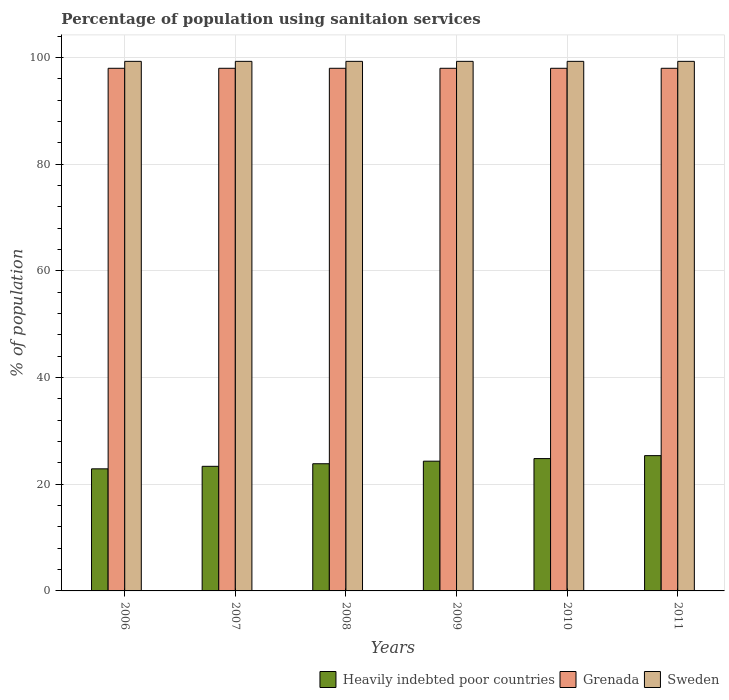How many different coloured bars are there?
Provide a short and direct response. 3. How many bars are there on the 4th tick from the right?
Your answer should be very brief. 3. In how many cases, is the number of bars for a given year not equal to the number of legend labels?
Keep it short and to the point. 0. What is the percentage of population using sanitaion services in Heavily indebted poor countries in 2009?
Keep it short and to the point. 24.33. Across all years, what is the maximum percentage of population using sanitaion services in Heavily indebted poor countries?
Offer a terse response. 25.37. Across all years, what is the minimum percentage of population using sanitaion services in Heavily indebted poor countries?
Offer a very short reply. 22.89. In which year was the percentage of population using sanitaion services in Sweden maximum?
Provide a succinct answer. 2006. What is the total percentage of population using sanitaion services in Grenada in the graph?
Make the answer very short. 588. What is the difference between the percentage of population using sanitaion services in Sweden in 2008 and that in 2011?
Provide a succinct answer. 0. What is the difference between the percentage of population using sanitaion services in Heavily indebted poor countries in 2010 and the percentage of population using sanitaion services in Sweden in 2006?
Make the answer very short. -74.49. What is the average percentage of population using sanitaion services in Sweden per year?
Give a very brief answer. 99.3. In the year 2010, what is the difference between the percentage of population using sanitaion services in Grenada and percentage of population using sanitaion services in Heavily indebted poor countries?
Give a very brief answer. 73.19. In how many years, is the percentage of population using sanitaion services in Heavily indebted poor countries greater than 76 %?
Your answer should be very brief. 0. What is the ratio of the percentage of population using sanitaion services in Heavily indebted poor countries in 2007 to that in 2011?
Keep it short and to the point. 0.92. Is the percentage of population using sanitaion services in Sweden in 2007 less than that in 2011?
Make the answer very short. No. What is the difference between the highest and the second highest percentage of population using sanitaion services in Heavily indebted poor countries?
Your answer should be compact. 0.55. What is the difference between the highest and the lowest percentage of population using sanitaion services in Sweden?
Your response must be concise. 0. In how many years, is the percentage of population using sanitaion services in Heavily indebted poor countries greater than the average percentage of population using sanitaion services in Heavily indebted poor countries taken over all years?
Provide a short and direct response. 3. What does the 3rd bar from the right in 2008 represents?
Your answer should be very brief. Heavily indebted poor countries. How many years are there in the graph?
Give a very brief answer. 6. How are the legend labels stacked?
Offer a terse response. Horizontal. What is the title of the graph?
Your response must be concise. Percentage of population using sanitaion services. Does "World" appear as one of the legend labels in the graph?
Your answer should be very brief. No. What is the label or title of the X-axis?
Offer a terse response. Years. What is the label or title of the Y-axis?
Your answer should be compact. % of population. What is the % of population of Heavily indebted poor countries in 2006?
Give a very brief answer. 22.89. What is the % of population of Sweden in 2006?
Your response must be concise. 99.3. What is the % of population of Heavily indebted poor countries in 2007?
Your answer should be compact. 23.37. What is the % of population of Sweden in 2007?
Make the answer very short. 99.3. What is the % of population of Heavily indebted poor countries in 2008?
Offer a very short reply. 23.85. What is the % of population in Sweden in 2008?
Your answer should be compact. 99.3. What is the % of population of Heavily indebted poor countries in 2009?
Provide a succinct answer. 24.33. What is the % of population in Grenada in 2009?
Make the answer very short. 98. What is the % of population of Sweden in 2009?
Make the answer very short. 99.3. What is the % of population in Heavily indebted poor countries in 2010?
Your response must be concise. 24.81. What is the % of population of Grenada in 2010?
Provide a succinct answer. 98. What is the % of population in Sweden in 2010?
Your response must be concise. 99.3. What is the % of population in Heavily indebted poor countries in 2011?
Offer a very short reply. 25.37. What is the % of population in Sweden in 2011?
Your answer should be compact. 99.3. Across all years, what is the maximum % of population of Heavily indebted poor countries?
Give a very brief answer. 25.37. Across all years, what is the maximum % of population of Grenada?
Provide a short and direct response. 98. Across all years, what is the maximum % of population in Sweden?
Offer a terse response. 99.3. Across all years, what is the minimum % of population of Heavily indebted poor countries?
Give a very brief answer. 22.89. Across all years, what is the minimum % of population of Grenada?
Your response must be concise. 98. Across all years, what is the minimum % of population of Sweden?
Offer a terse response. 99.3. What is the total % of population of Heavily indebted poor countries in the graph?
Your answer should be compact. 144.62. What is the total % of population of Grenada in the graph?
Offer a terse response. 588. What is the total % of population of Sweden in the graph?
Offer a very short reply. 595.8. What is the difference between the % of population of Heavily indebted poor countries in 2006 and that in 2007?
Your answer should be compact. -0.47. What is the difference between the % of population of Sweden in 2006 and that in 2007?
Your response must be concise. 0. What is the difference between the % of population of Heavily indebted poor countries in 2006 and that in 2008?
Your answer should be very brief. -0.95. What is the difference between the % of population in Grenada in 2006 and that in 2008?
Give a very brief answer. 0. What is the difference between the % of population of Heavily indebted poor countries in 2006 and that in 2009?
Your answer should be very brief. -1.43. What is the difference between the % of population of Grenada in 2006 and that in 2009?
Provide a short and direct response. 0. What is the difference between the % of population of Heavily indebted poor countries in 2006 and that in 2010?
Provide a succinct answer. -1.92. What is the difference between the % of population in Sweden in 2006 and that in 2010?
Give a very brief answer. 0. What is the difference between the % of population in Heavily indebted poor countries in 2006 and that in 2011?
Offer a terse response. -2.47. What is the difference between the % of population in Sweden in 2006 and that in 2011?
Keep it short and to the point. 0. What is the difference between the % of population of Heavily indebted poor countries in 2007 and that in 2008?
Give a very brief answer. -0.48. What is the difference between the % of population in Grenada in 2007 and that in 2008?
Ensure brevity in your answer.  0. What is the difference between the % of population of Sweden in 2007 and that in 2008?
Keep it short and to the point. 0. What is the difference between the % of population in Heavily indebted poor countries in 2007 and that in 2009?
Your answer should be compact. -0.96. What is the difference between the % of population of Heavily indebted poor countries in 2007 and that in 2010?
Ensure brevity in your answer.  -1.45. What is the difference between the % of population of Grenada in 2007 and that in 2010?
Your answer should be very brief. 0. What is the difference between the % of population in Heavily indebted poor countries in 2007 and that in 2011?
Provide a succinct answer. -2. What is the difference between the % of population of Heavily indebted poor countries in 2008 and that in 2009?
Offer a terse response. -0.48. What is the difference between the % of population of Grenada in 2008 and that in 2009?
Your answer should be compact. 0. What is the difference between the % of population of Sweden in 2008 and that in 2009?
Provide a short and direct response. 0. What is the difference between the % of population in Heavily indebted poor countries in 2008 and that in 2010?
Give a very brief answer. -0.97. What is the difference between the % of population of Sweden in 2008 and that in 2010?
Offer a very short reply. 0. What is the difference between the % of population in Heavily indebted poor countries in 2008 and that in 2011?
Offer a terse response. -1.52. What is the difference between the % of population in Heavily indebted poor countries in 2009 and that in 2010?
Ensure brevity in your answer.  -0.49. What is the difference between the % of population in Grenada in 2009 and that in 2010?
Give a very brief answer. 0. What is the difference between the % of population of Heavily indebted poor countries in 2009 and that in 2011?
Offer a terse response. -1.04. What is the difference between the % of population of Grenada in 2009 and that in 2011?
Offer a very short reply. 0. What is the difference between the % of population in Sweden in 2009 and that in 2011?
Give a very brief answer. 0. What is the difference between the % of population of Heavily indebted poor countries in 2010 and that in 2011?
Provide a succinct answer. -0.55. What is the difference between the % of population in Grenada in 2010 and that in 2011?
Your answer should be compact. 0. What is the difference between the % of population in Sweden in 2010 and that in 2011?
Offer a very short reply. 0. What is the difference between the % of population in Heavily indebted poor countries in 2006 and the % of population in Grenada in 2007?
Your answer should be compact. -75.11. What is the difference between the % of population in Heavily indebted poor countries in 2006 and the % of population in Sweden in 2007?
Provide a succinct answer. -76.41. What is the difference between the % of population of Grenada in 2006 and the % of population of Sweden in 2007?
Your response must be concise. -1.3. What is the difference between the % of population of Heavily indebted poor countries in 2006 and the % of population of Grenada in 2008?
Your answer should be compact. -75.11. What is the difference between the % of population in Heavily indebted poor countries in 2006 and the % of population in Sweden in 2008?
Make the answer very short. -76.41. What is the difference between the % of population of Heavily indebted poor countries in 2006 and the % of population of Grenada in 2009?
Offer a very short reply. -75.11. What is the difference between the % of population of Heavily indebted poor countries in 2006 and the % of population of Sweden in 2009?
Make the answer very short. -76.41. What is the difference between the % of population of Grenada in 2006 and the % of population of Sweden in 2009?
Offer a terse response. -1.3. What is the difference between the % of population of Heavily indebted poor countries in 2006 and the % of population of Grenada in 2010?
Give a very brief answer. -75.11. What is the difference between the % of population in Heavily indebted poor countries in 2006 and the % of population in Sweden in 2010?
Provide a short and direct response. -76.41. What is the difference between the % of population in Grenada in 2006 and the % of population in Sweden in 2010?
Your answer should be very brief. -1.3. What is the difference between the % of population of Heavily indebted poor countries in 2006 and the % of population of Grenada in 2011?
Ensure brevity in your answer.  -75.11. What is the difference between the % of population of Heavily indebted poor countries in 2006 and the % of population of Sweden in 2011?
Offer a terse response. -76.41. What is the difference between the % of population of Grenada in 2006 and the % of population of Sweden in 2011?
Provide a short and direct response. -1.3. What is the difference between the % of population of Heavily indebted poor countries in 2007 and the % of population of Grenada in 2008?
Your response must be concise. -74.63. What is the difference between the % of population in Heavily indebted poor countries in 2007 and the % of population in Sweden in 2008?
Make the answer very short. -75.93. What is the difference between the % of population of Heavily indebted poor countries in 2007 and the % of population of Grenada in 2009?
Ensure brevity in your answer.  -74.63. What is the difference between the % of population in Heavily indebted poor countries in 2007 and the % of population in Sweden in 2009?
Make the answer very short. -75.93. What is the difference between the % of population in Grenada in 2007 and the % of population in Sweden in 2009?
Your response must be concise. -1.3. What is the difference between the % of population in Heavily indebted poor countries in 2007 and the % of population in Grenada in 2010?
Keep it short and to the point. -74.63. What is the difference between the % of population in Heavily indebted poor countries in 2007 and the % of population in Sweden in 2010?
Your answer should be compact. -75.93. What is the difference between the % of population of Grenada in 2007 and the % of population of Sweden in 2010?
Your response must be concise. -1.3. What is the difference between the % of population in Heavily indebted poor countries in 2007 and the % of population in Grenada in 2011?
Your answer should be very brief. -74.63. What is the difference between the % of population of Heavily indebted poor countries in 2007 and the % of population of Sweden in 2011?
Your answer should be compact. -75.93. What is the difference between the % of population in Heavily indebted poor countries in 2008 and the % of population in Grenada in 2009?
Keep it short and to the point. -74.15. What is the difference between the % of population of Heavily indebted poor countries in 2008 and the % of population of Sweden in 2009?
Your answer should be compact. -75.45. What is the difference between the % of population of Grenada in 2008 and the % of population of Sweden in 2009?
Provide a succinct answer. -1.3. What is the difference between the % of population of Heavily indebted poor countries in 2008 and the % of population of Grenada in 2010?
Provide a succinct answer. -74.15. What is the difference between the % of population in Heavily indebted poor countries in 2008 and the % of population in Sweden in 2010?
Keep it short and to the point. -75.45. What is the difference between the % of population in Grenada in 2008 and the % of population in Sweden in 2010?
Provide a succinct answer. -1.3. What is the difference between the % of population of Heavily indebted poor countries in 2008 and the % of population of Grenada in 2011?
Your answer should be very brief. -74.15. What is the difference between the % of population in Heavily indebted poor countries in 2008 and the % of population in Sweden in 2011?
Provide a succinct answer. -75.45. What is the difference between the % of population in Grenada in 2008 and the % of population in Sweden in 2011?
Your answer should be compact. -1.3. What is the difference between the % of population in Heavily indebted poor countries in 2009 and the % of population in Grenada in 2010?
Give a very brief answer. -73.67. What is the difference between the % of population of Heavily indebted poor countries in 2009 and the % of population of Sweden in 2010?
Make the answer very short. -74.97. What is the difference between the % of population of Grenada in 2009 and the % of population of Sweden in 2010?
Your response must be concise. -1.3. What is the difference between the % of population in Heavily indebted poor countries in 2009 and the % of population in Grenada in 2011?
Keep it short and to the point. -73.67. What is the difference between the % of population in Heavily indebted poor countries in 2009 and the % of population in Sweden in 2011?
Offer a terse response. -74.97. What is the difference between the % of population of Heavily indebted poor countries in 2010 and the % of population of Grenada in 2011?
Your answer should be very brief. -73.19. What is the difference between the % of population in Heavily indebted poor countries in 2010 and the % of population in Sweden in 2011?
Your response must be concise. -74.49. What is the difference between the % of population of Grenada in 2010 and the % of population of Sweden in 2011?
Make the answer very short. -1.3. What is the average % of population in Heavily indebted poor countries per year?
Provide a short and direct response. 24.1. What is the average % of population of Sweden per year?
Provide a short and direct response. 99.3. In the year 2006, what is the difference between the % of population of Heavily indebted poor countries and % of population of Grenada?
Offer a very short reply. -75.11. In the year 2006, what is the difference between the % of population of Heavily indebted poor countries and % of population of Sweden?
Your response must be concise. -76.41. In the year 2007, what is the difference between the % of population of Heavily indebted poor countries and % of population of Grenada?
Your answer should be compact. -74.63. In the year 2007, what is the difference between the % of population of Heavily indebted poor countries and % of population of Sweden?
Keep it short and to the point. -75.93. In the year 2007, what is the difference between the % of population of Grenada and % of population of Sweden?
Offer a terse response. -1.3. In the year 2008, what is the difference between the % of population of Heavily indebted poor countries and % of population of Grenada?
Provide a succinct answer. -74.15. In the year 2008, what is the difference between the % of population in Heavily indebted poor countries and % of population in Sweden?
Ensure brevity in your answer.  -75.45. In the year 2009, what is the difference between the % of population in Heavily indebted poor countries and % of population in Grenada?
Ensure brevity in your answer.  -73.67. In the year 2009, what is the difference between the % of population of Heavily indebted poor countries and % of population of Sweden?
Offer a very short reply. -74.97. In the year 2010, what is the difference between the % of population of Heavily indebted poor countries and % of population of Grenada?
Provide a succinct answer. -73.19. In the year 2010, what is the difference between the % of population of Heavily indebted poor countries and % of population of Sweden?
Make the answer very short. -74.49. In the year 2011, what is the difference between the % of population of Heavily indebted poor countries and % of population of Grenada?
Your answer should be compact. -72.63. In the year 2011, what is the difference between the % of population in Heavily indebted poor countries and % of population in Sweden?
Offer a terse response. -73.93. What is the ratio of the % of population in Heavily indebted poor countries in 2006 to that in 2007?
Make the answer very short. 0.98. What is the ratio of the % of population of Heavily indebted poor countries in 2006 to that in 2008?
Make the answer very short. 0.96. What is the ratio of the % of population in Heavily indebted poor countries in 2006 to that in 2009?
Your answer should be very brief. 0.94. What is the ratio of the % of population of Grenada in 2006 to that in 2009?
Provide a succinct answer. 1. What is the ratio of the % of population in Heavily indebted poor countries in 2006 to that in 2010?
Give a very brief answer. 0.92. What is the ratio of the % of population in Grenada in 2006 to that in 2010?
Provide a succinct answer. 1. What is the ratio of the % of population of Heavily indebted poor countries in 2006 to that in 2011?
Offer a very short reply. 0.9. What is the ratio of the % of population of Heavily indebted poor countries in 2007 to that in 2008?
Offer a terse response. 0.98. What is the ratio of the % of population in Sweden in 2007 to that in 2008?
Give a very brief answer. 1. What is the ratio of the % of population of Heavily indebted poor countries in 2007 to that in 2009?
Provide a short and direct response. 0.96. What is the ratio of the % of population in Grenada in 2007 to that in 2009?
Make the answer very short. 1. What is the ratio of the % of population of Heavily indebted poor countries in 2007 to that in 2010?
Your answer should be compact. 0.94. What is the ratio of the % of population of Grenada in 2007 to that in 2010?
Provide a short and direct response. 1. What is the ratio of the % of population in Sweden in 2007 to that in 2010?
Ensure brevity in your answer.  1. What is the ratio of the % of population of Heavily indebted poor countries in 2007 to that in 2011?
Ensure brevity in your answer.  0.92. What is the ratio of the % of population of Grenada in 2007 to that in 2011?
Provide a short and direct response. 1. What is the ratio of the % of population in Heavily indebted poor countries in 2008 to that in 2009?
Keep it short and to the point. 0.98. What is the ratio of the % of population in Sweden in 2008 to that in 2009?
Your answer should be compact. 1. What is the ratio of the % of population in Heavily indebted poor countries in 2008 to that in 2011?
Keep it short and to the point. 0.94. What is the ratio of the % of population in Grenada in 2008 to that in 2011?
Ensure brevity in your answer.  1. What is the ratio of the % of population of Sweden in 2008 to that in 2011?
Your response must be concise. 1. What is the ratio of the % of population in Heavily indebted poor countries in 2009 to that in 2010?
Provide a succinct answer. 0.98. What is the ratio of the % of population in Grenada in 2009 to that in 2010?
Provide a short and direct response. 1. What is the ratio of the % of population in Heavily indebted poor countries in 2010 to that in 2011?
Offer a very short reply. 0.98. What is the difference between the highest and the second highest % of population of Heavily indebted poor countries?
Keep it short and to the point. 0.55. What is the difference between the highest and the second highest % of population of Sweden?
Offer a terse response. 0. What is the difference between the highest and the lowest % of population in Heavily indebted poor countries?
Your answer should be compact. 2.47. What is the difference between the highest and the lowest % of population in Grenada?
Keep it short and to the point. 0. What is the difference between the highest and the lowest % of population in Sweden?
Provide a succinct answer. 0. 